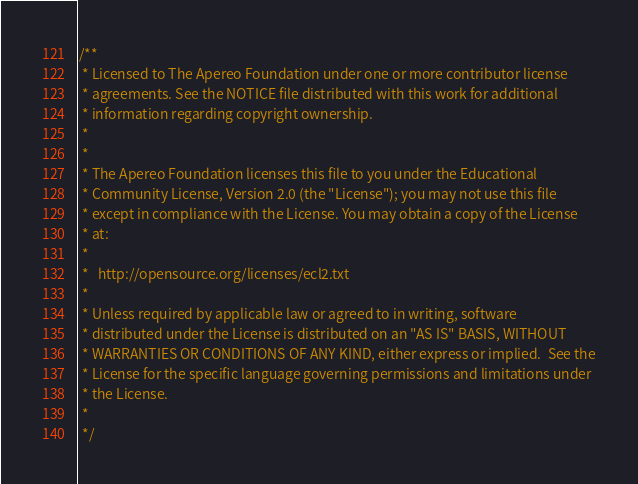Convert code to text. <code><loc_0><loc_0><loc_500><loc_500><_Java_>/**
 * Licensed to The Apereo Foundation under one or more contributor license
 * agreements. See the NOTICE file distributed with this work for additional
 * information regarding copyright ownership.
 *
 *
 * The Apereo Foundation licenses this file to you under the Educational
 * Community License, Version 2.0 (the "License"); you may not use this file
 * except in compliance with the License. You may obtain a copy of the License
 * at:
 *
 *   http://opensource.org/licenses/ecl2.txt
 *
 * Unless required by applicable law or agreed to in writing, software
 * distributed under the License is distributed on an "AS IS" BASIS, WITHOUT
 * WARRANTIES OR CONDITIONS OF ANY KIND, either express or implied.  See the
 * License for the specific language governing permissions and limitations under
 * the License.
 *
 */</code> 